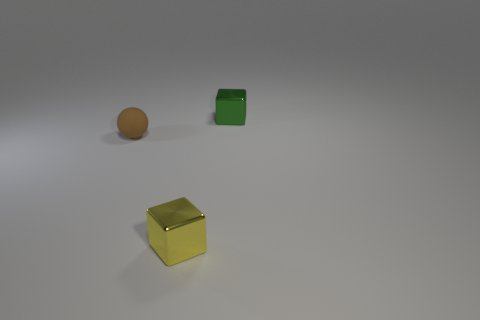Add 2 metal cubes. How many objects exist? 5 Subtract all spheres. How many objects are left? 2 Add 3 tiny green cubes. How many tiny green cubes exist? 4 Subtract 0 cyan balls. How many objects are left? 3 Subtract all small metallic things. Subtract all gray spheres. How many objects are left? 1 Add 3 yellow shiny objects. How many yellow shiny objects are left? 4 